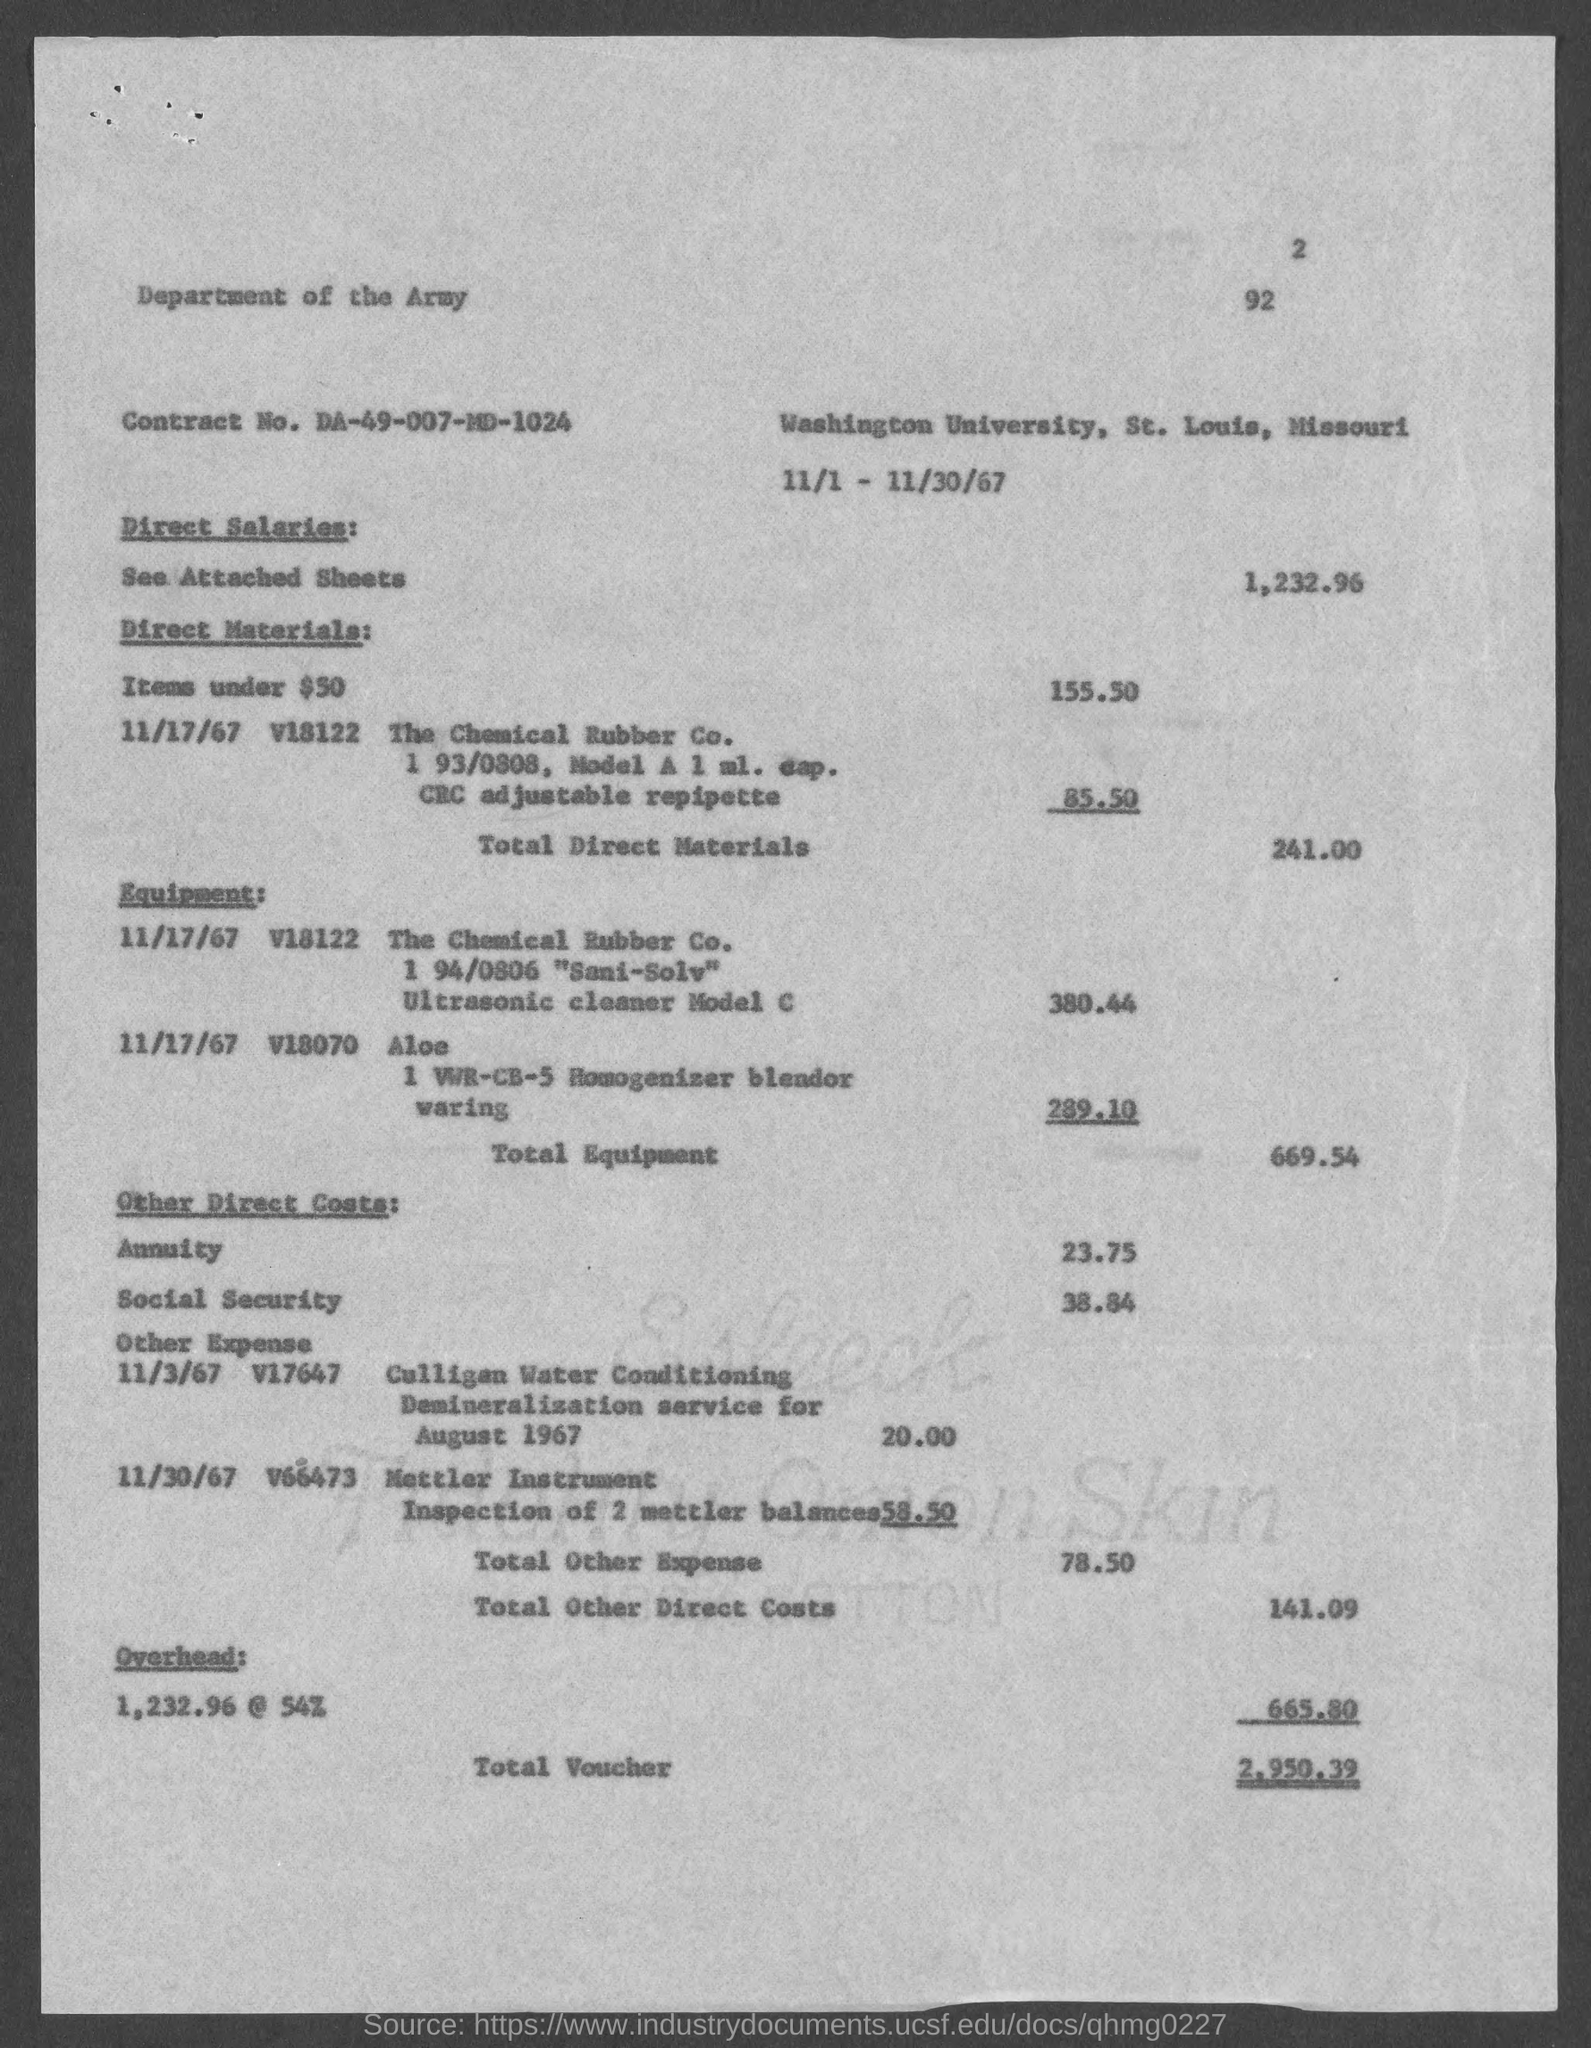What is the Contract No. given in the document?
Offer a very short reply. DA-49-007-MD-1024. What is the direct salaries cost mentioned in the document?
Offer a very short reply. 1,232.96. What is the total direct materials cost given in the document?
Keep it short and to the point. 241.00. What is the total equipment cost given in the document?
Your answer should be compact. 669.54. How much is the overhead cost mentioned in the document?
Your answer should be very brief. 665.80. What is the total voucher amount given in the document?
Your response must be concise. 2,950.39. 